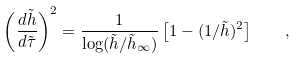Convert formula to latex. <formula><loc_0><loc_0><loc_500><loc_500>\left ( \frac { d \tilde { h } } { d \tilde { \tau } } \right ) ^ { 2 } = \frac { 1 } { \log ( \tilde { h } / { \tilde { h } _ { \infty } } ) } \left [ 1 - ( 1 / \tilde { h } ) ^ { 2 } \right ] \quad ,</formula> 